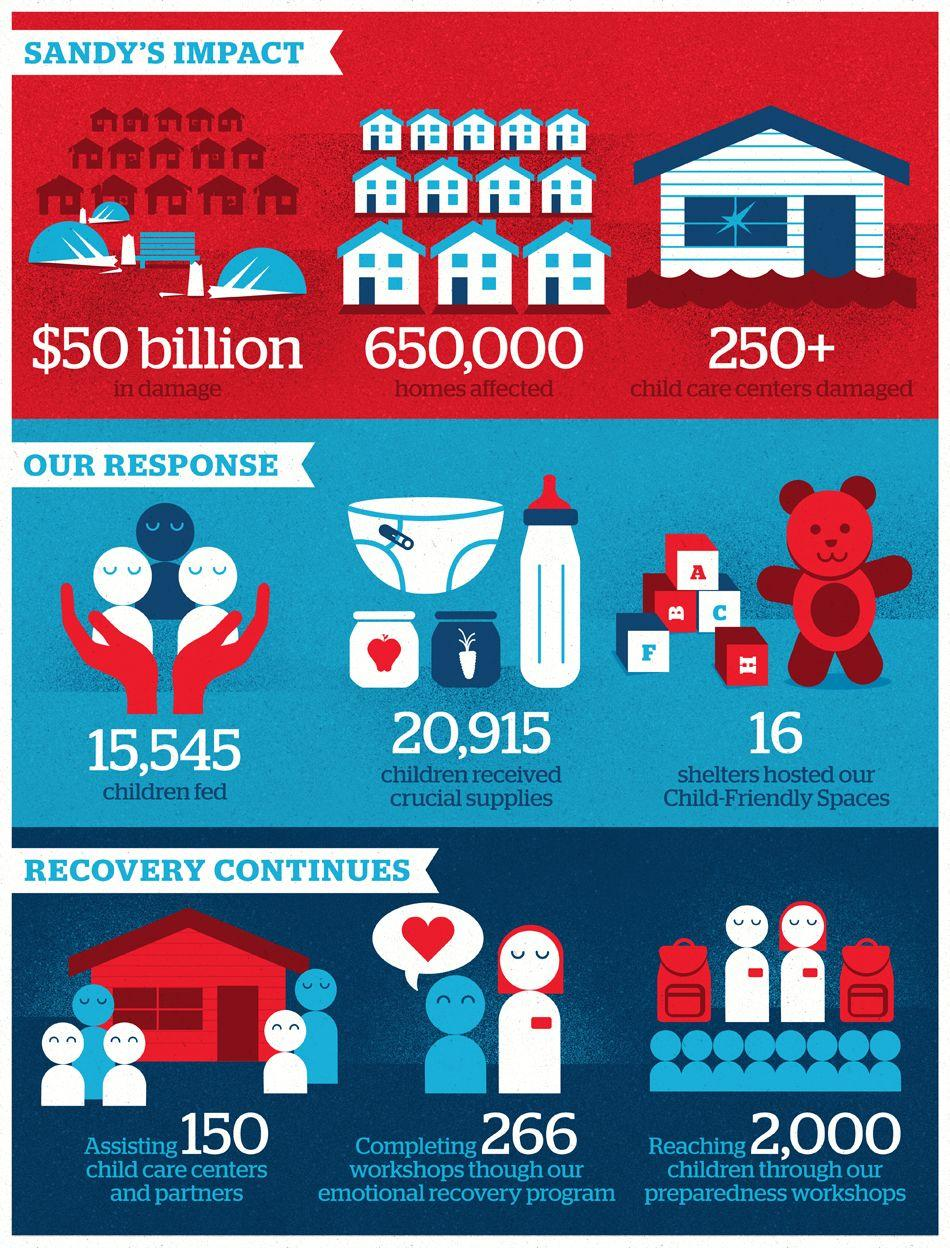Indicate a few pertinent items in this graphic. Approximately 650,000 homes were impacted by the devastating effects of Hurricane Sandy. During the Sandy hurricane, over 250 child care centers were severely damaged. It is estimated that a total of 20,915 children were impacted by the Sandy hurricane and received critical supplies to aid in their recovery. The damage caused by Sandy resulted in a cost of $50 billion. The emotional recovery program included the completion of 266 workshops. 